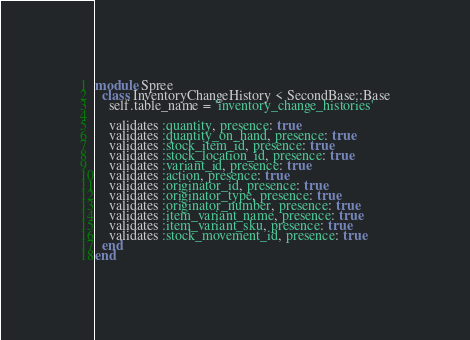Convert code to text. <code><loc_0><loc_0><loc_500><loc_500><_Ruby_>module Spree
  class InventoryChangeHistory < SecondBase::Base
    self.table_name = 'inventory_change_histories'

    validates :quantity, presence: true
    validates :quantity_on_hand, presence: true
    validates :stock_item_id, presence: true
    validates :stock_location_id, presence: true
    validates :variant_id, presence: true
    validates :action, presence: true
    validates :originator_id, presence: true
    validates :originator_type, presence: true
    validates :originator_number, presence: true
    validates :item_variant_name, presence: true
    validates :item_variant_sku, presence: true
    validates :stock_movement_id, presence: true
  end
end
</code> 